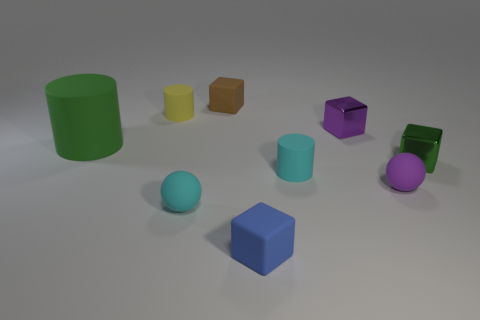Are the cylinder on the left side of the small yellow rubber object and the purple block made of the same material?
Your answer should be very brief. No. How many things are tiny cyan matte cylinders or tiny blue metal blocks?
Ensure brevity in your answer.  1. There is a cyan thing that is the same shape as the tiny yellow object; what size is it?
Offer a terse response. Small. How big is the green cylinder?
Your response must be concise. Large. Are there more tiny blocks on the right side of the small purple matte thing than large brown matte cylinders?
Offer a very short reply. Yes. Do the tiny matte cylinder to the right of the yellow cylinder and the tiny rubber ball that is left of the purple shiny block have the same color?
Your answer should be very brief. Yes. What is the material of the small cylinder that is behind the small shiny object that is left of the metallic cube in front of the tiny purple metal cube?
Make the answer very short. Rubber. Is the number of big green cylinders greater than the number of cubes?
Give a very brief answer. No. Are there any other things that have the same color as the big cylinder?
Provide a short and direct response. Yes. What size is the yellow object that is made of the same material as the tiny blue cube?
Provide a succinct answer. Small. 